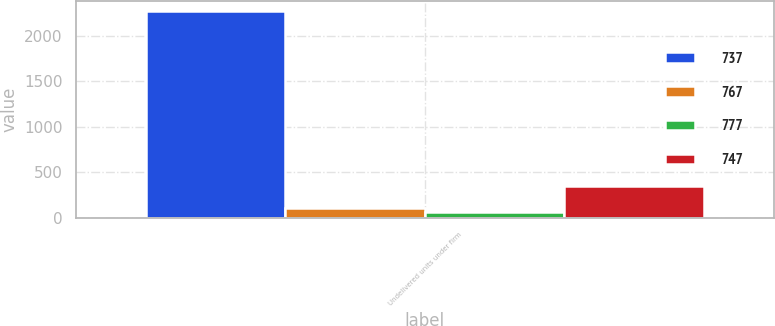<chart> <loc_0><loc_0><loc_500><loc_500><stacked_bar_chart><ecel><fcel>Undelivered units under firm<nl><fcel>737<fcel>2270<nl><fcel>767<fcel>114<nl><fcel>777<fcel>70<nl><fcel>747<fcel>350<nl></chart> 